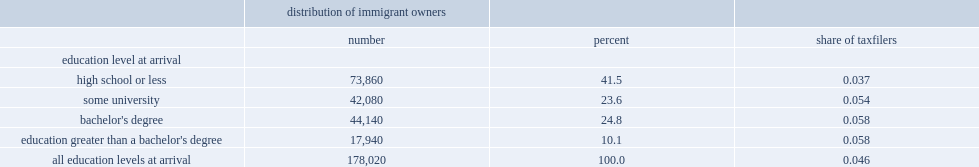What the percent of immigrants with a high-school education or less when they entered canada? 41.5. What the percent of immigrants with some university education when they entered canada? 23.6. What the percent of immigrants had some university education when they entered canada? 34.9. 